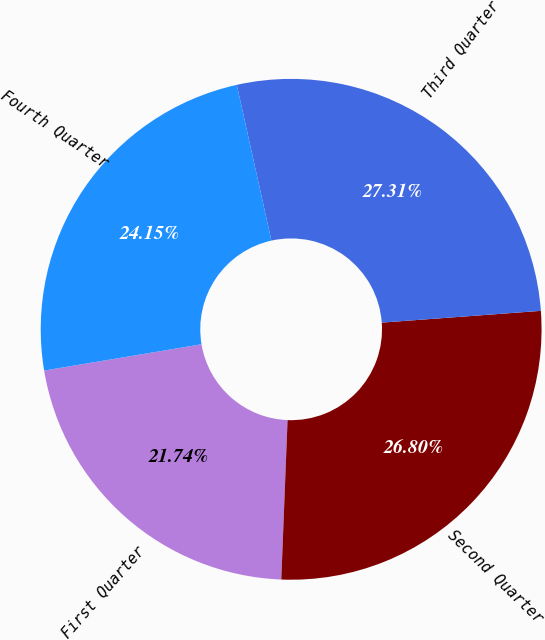<chart> <loc_0><loc_0><loc_500><loc_500><pie_chart><fcel>First Quarter<fcel>Second Quarter<fcel>Third Quarter<fcel>Fourth Quarter<nl><fcel>21.74%<fcel>26.8%<fcel>27.31%<fcel>24.15%<nl></chart> 